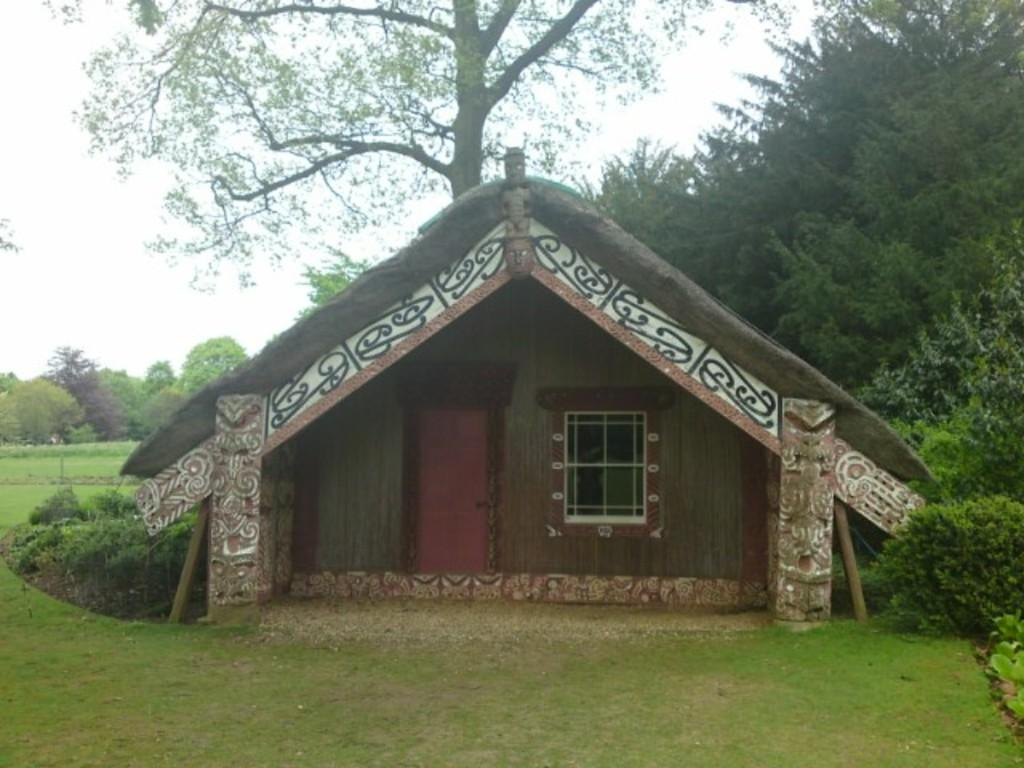What is the main structure in the center of the image? There is a hut in the center of the image. What can be seen around the hut in the image? There is greenery around the area of the image. What are the main features of the hut in the image? There is a door and a window in the center of the image. How many chickens can be seen in the image? There are no chickens present in the image. What type of deer is visible through the window in the image? There is no deer visible in the image, as there is no indication of any animals or objects beyond the window. 